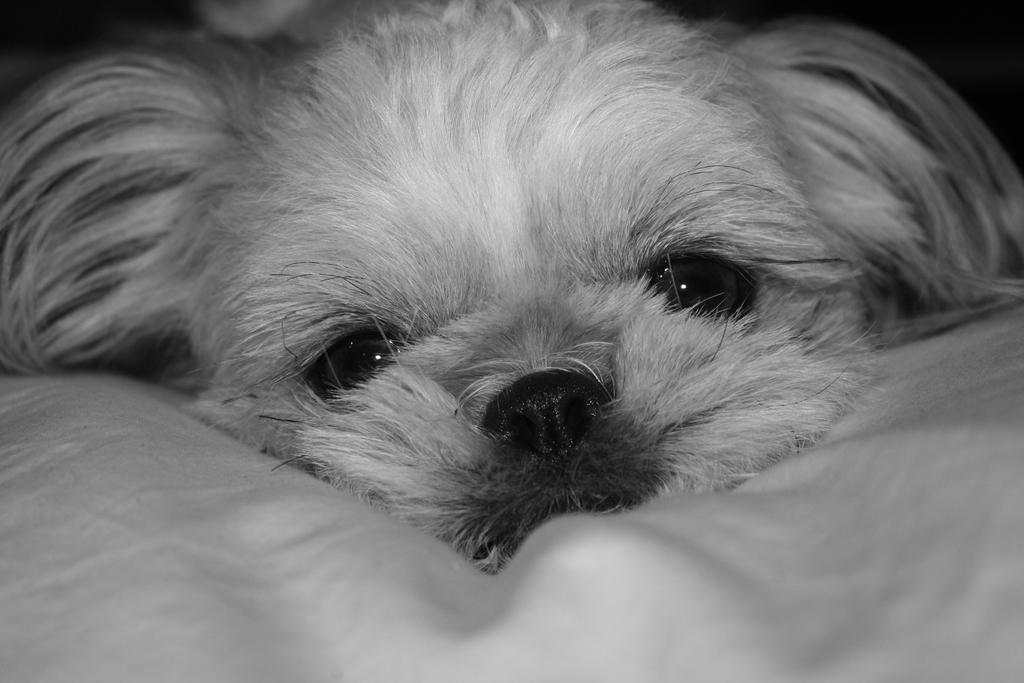What is the main subject of the image? The main subject of the image is a dog's face. What color scheme is used in the image? The image is in black and white color. Where is the drain located in the image? There is no drain present in the image; it features a dog's face in black and white. How many geese are visible in the image? There are no geese present in the image; it features a dog's face in black and white. 